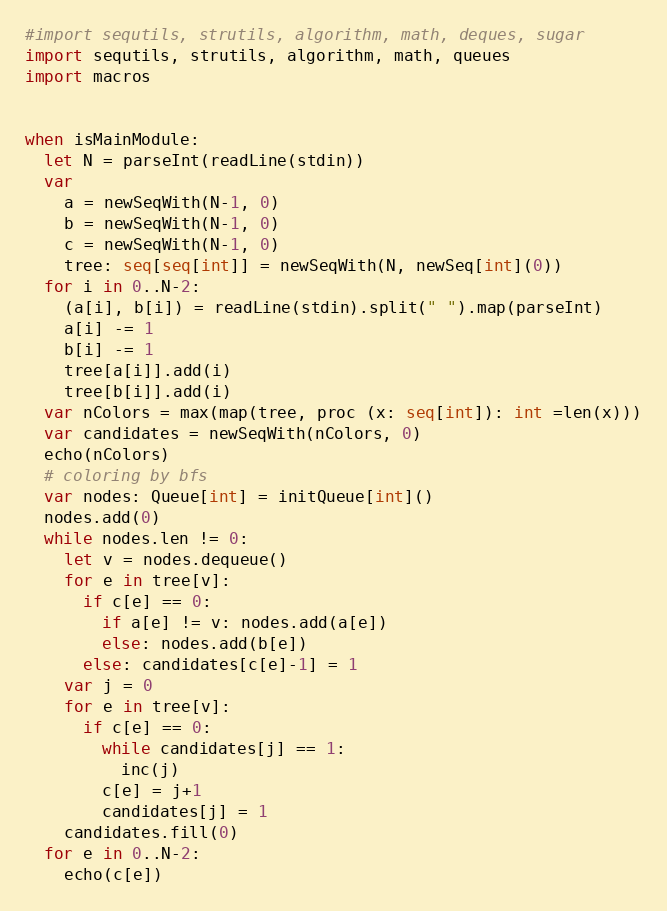<code> <loc_0><loc_0><loc_500><loc_500><_Nim_>#import sequtils, strutils, algorithm, math, deques, sugar
import sequtils, strutils, algorithm, math, queues
import macros


when isMainModule:
  let N = parseInt(readLine(stdin))
  var
    a = newSeqWith(N-1, 0)
    b = newSeqWith(N-1, 0)
    c = newSeqWith(N-1, 0)
    tree: seq[seq[int]] = newSeqWith(N, newSeq[int](0))
  for i in 0..N-2:
    (a[i], b[i]) = readLine(stdin).split(" ").map(parseInt)
    a[i] -= 1
    b[i] -= 1
    tree[a[i]].add(i)
    tree[b[i]].add(i)
  var nColors = max(map(tree, proc (x: seq[int]): int =len(x)))
  var candidates = newSeqWith(nColors, 0)
  echo(nColors)
  # coloring by bfs
  var nodes: Queue[int] = initQueue[int]()
  nodes.add(0)
  while nodes.len != 0:
    let v = nodes.dequeue()
    for e in tree[v]:
      if c[e] == 0:
        if a[e] != v: nodes.add(a[e])
        else: nodes.add(b[e])
      else: candidates[c[e]-1] = 1
    var j = 0
    for e in tree[v]:
      if c[e] == 0:
        while candidates[j] == 1:
          inc(j)
        c[e] = j+1
        candidates[j] = 1
    candidates.fill(0)
  for e in 0..N-2:
    echo(c[e])</code> 